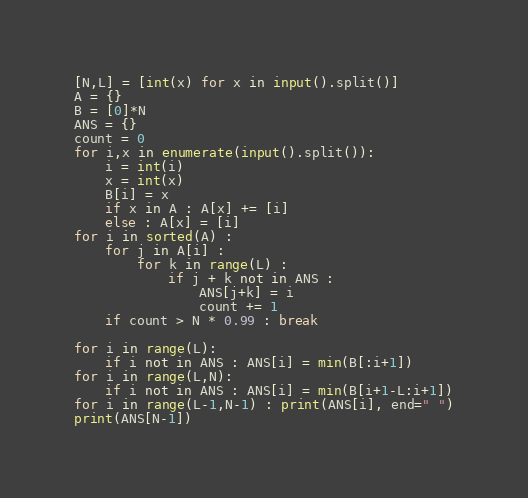<code> <loc_0><loc_0><loc_500><loc_500><_Python_>[N,L] = [int(x) for x in input().split()]
A = {}
B = [0]*N
ANS = {}
count = 0
for i,x in enumerate(input().split()):
    i = int(i)
    x = int(x)
    B[i] = x
    if x in A : A[x] += [i]
    else : A[x] = [i]
for i in sorted(A) :
    for j in A[i] :
        for k in range(L) :
            if j + k not in ANS :
                ANS[j+k] = i
                count += 1
    if count > N * 0.99 : break
        
for i in range(L):
    if i not in ANS : ANS[i] = min(B[:i+1])
for i in range(L,N):
    if i not in ANS : ANS[i] = min(B[i+1-L:i+1])
for i in range(L-1,N-1) : print(ANS[i], end=" ")
print(ANS[N-1])</code> 